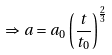<formula> <loc_0><loc_0><loc_500><loc_500>\Rightarrow a = a _ { 0 } \left ( \frac { t } { t _ { 0 } } \right ) ^ { \frac { 2 } { 3 } }</formula> 